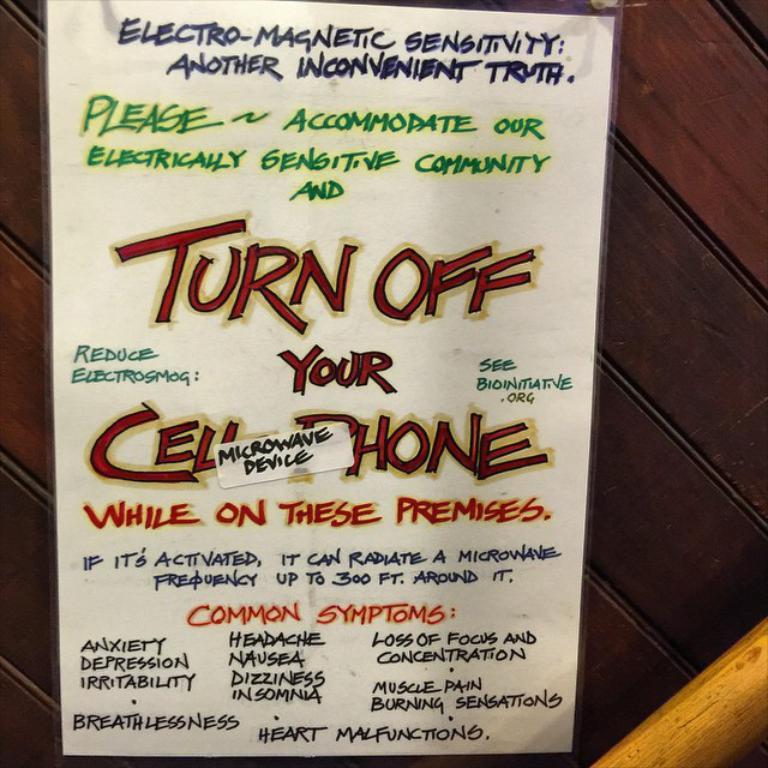What does the sign say to do?
Your response must be concise. Turn off your cell phone. Are you obey?
Your answer should be compact. Unanswerable. 